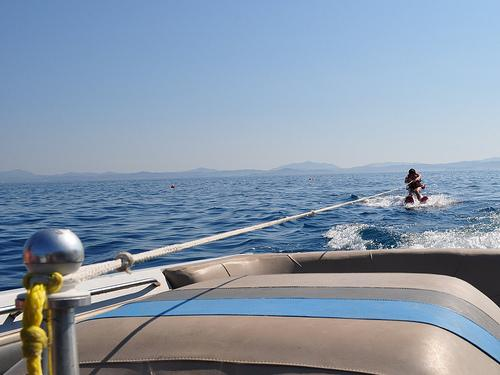What can be seen in the background of the image? Mountains in the background can be seen in the image. Describe the condition of the water around the boat and the water skier. There are small waves formed by the boat and choppy water formed by the skier. Identify the color of the rope used for waterskiing. The rope used for waterskiing is white. What is the color of the sky in the image? The sky is blue and white. What is the color of the water skis? The water skis are red. Describe the boat in the image. The boat features a blue and gray leather covering, a silver hitch, a metal pole, and back seating. It can be seen pulling a skier. In a referential expression, describe the person waterskiing. A person with short hair is waterskiing, crouched and holding a white rope, wearing water skis. In a product advertisement, describe the type of activity being showcased in the image. Experience the thrill of waterskiing in crystal-clear blue ocean water, under clear blue skies and beautiful mountains in the background, with our top-notch red water skis. Choose the right option for this VQA task: What is the white rope connected to? (a) The skier. (b) The boat. (c) The mountains. (a) The skier and (b) The boat. Observe the purple mountains in the background. No, it's not mentioned in the image. Take a look at the birds flying in the sky. There is no mention of any birds in the image. It only states that the sky is blue and clear. Notice the large crowd of people on the boat. There is no mention of any crowd or multiple people on the boat in the image. Could you please find the green rope in the image? There is no green rope in the image. Ropes are mentioned having colors white and yellow, but not green. Can you locate a black leather covering on the boat? There is a blue and gray leather covering on the boat mentioned, but not a black one. Do you see the beautiful rainbow in the sky? The sky is described only as clear blue and no mention of a rainbow is made. Find the brown boat in the image. There is no mention of a brown boat in the image. Only the back of a boat is mentioned. Do you see the woman with long hair waterskiing? The person waterskiing is mentioned to have short hair, no gender is specified. Check out that beautiful sunset in the picture. There is only mention of clear blue sky with no clouds, no sunset is mentioned. Look at the floating pink water buoy. There is a mention of a red water buoy, not pink. 